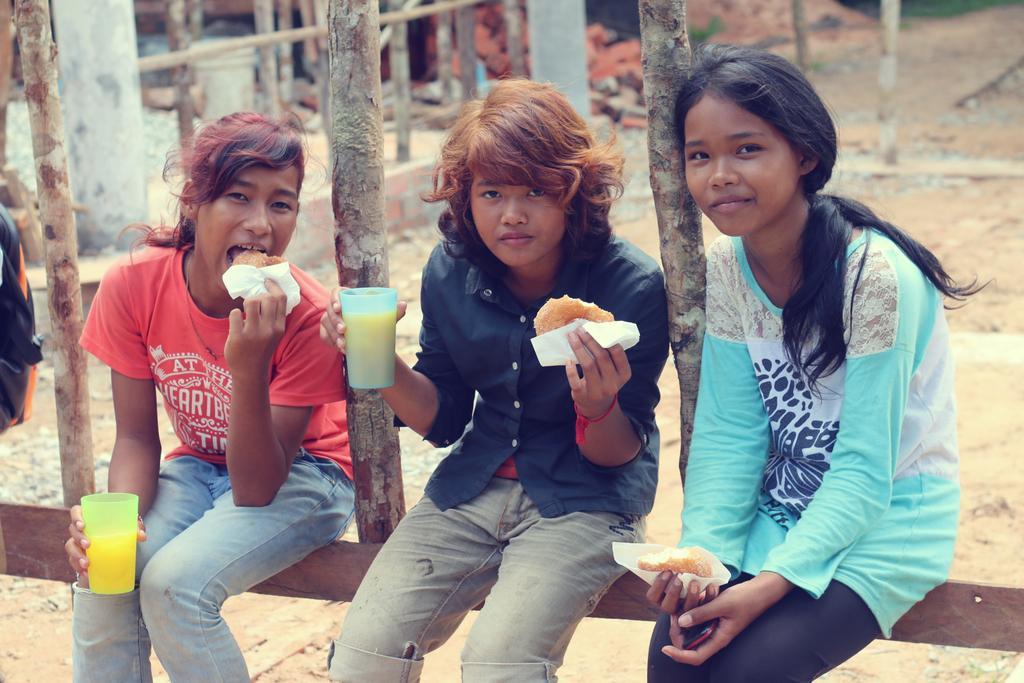Could you give a brief overview of what you see in this image? In this picture I can see few girls holding some food in their hands and I can see couple of them holding glasses in their hands and another woman holding a mobile in her hand and I can see few wooden sticks. 